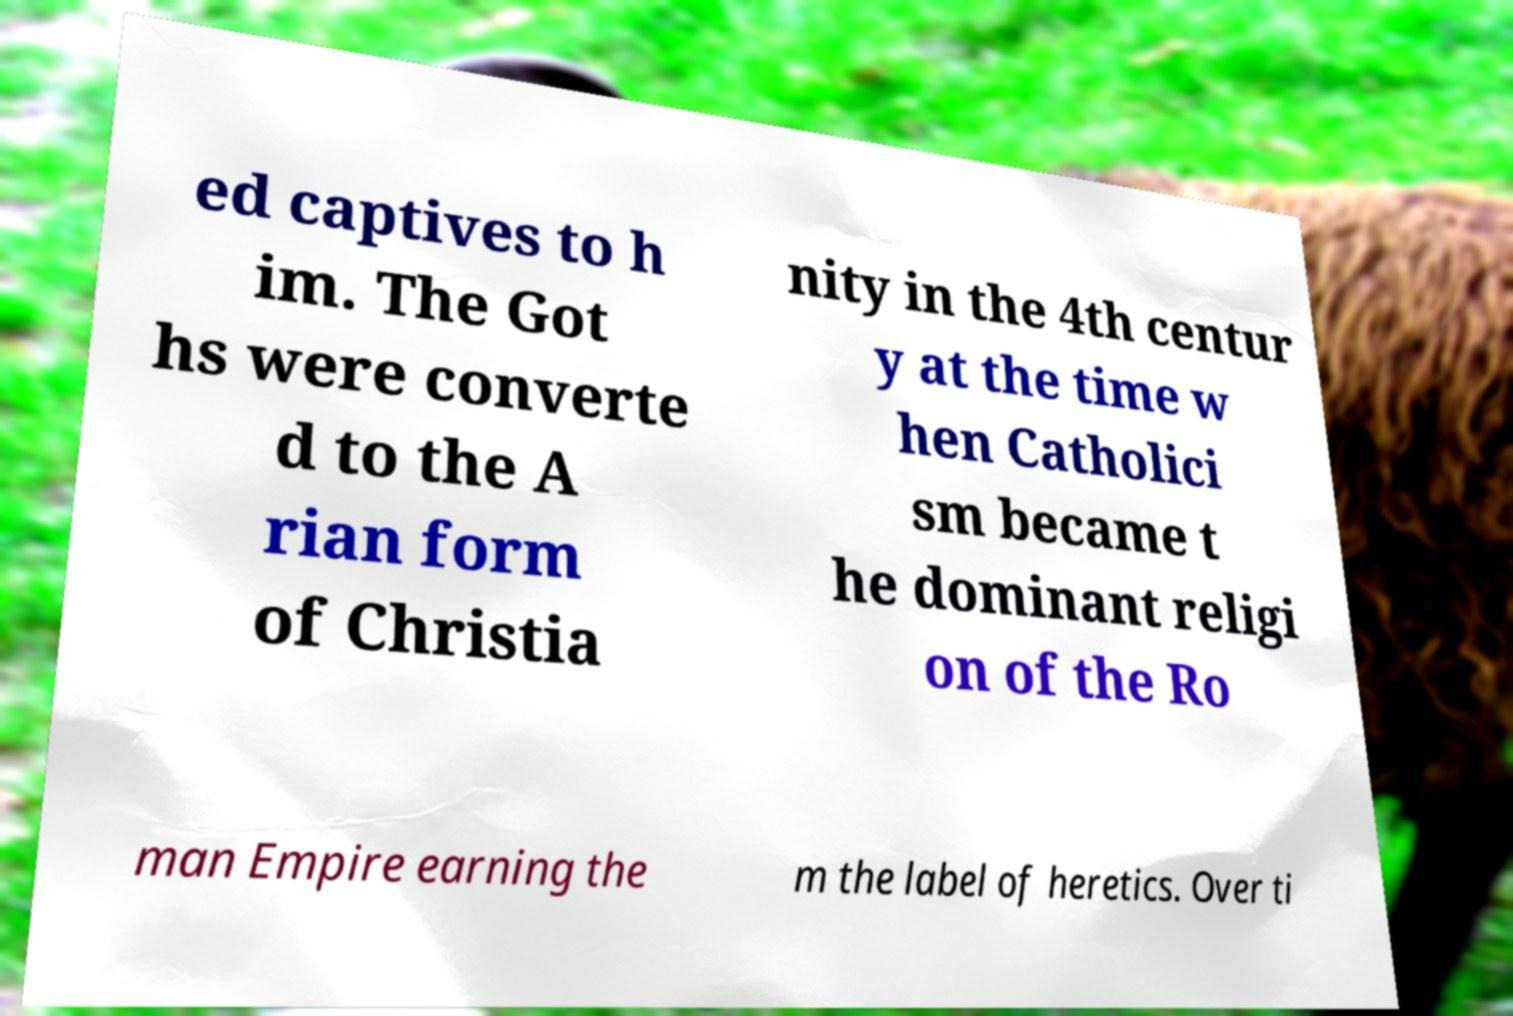There's text embedded in this image that I need extracted. Can you transcribe it verbatim? ed captives to h im. The Got hs were converte d to the A rian form of Christia nity in the 4th centur y at the time w hen Catholici sm became t he dominant religi on of the Ro man Empire earning the m the label of heretics. Over ti 